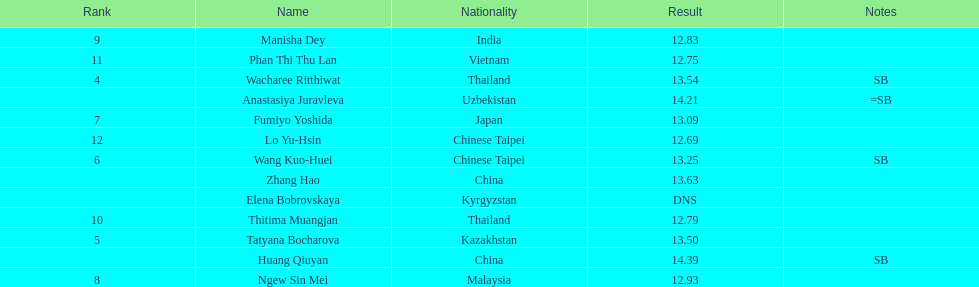What was the average result of the top three jumpers? 14.08. 